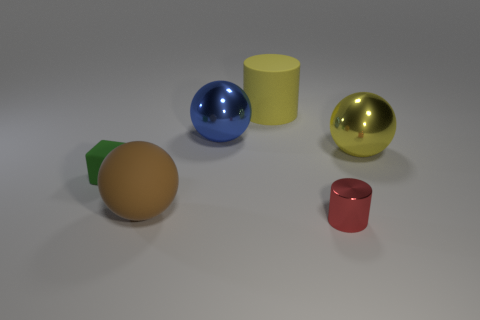Add 4 tiny green metal cubes. How many objects exist? 10 Subtract all cubes. How many objects are left? 5 Add 3 large yellow matte things. How many large yellow matte things are left? 4 Add 6 yellow rubber things. How many yellow rubber things exist? 7 Subtract 0 brown cubes. How many objects are left? 6 Subtract all big yellow metallic things. Subtract all big metallic objects. How many objects are left? 3 